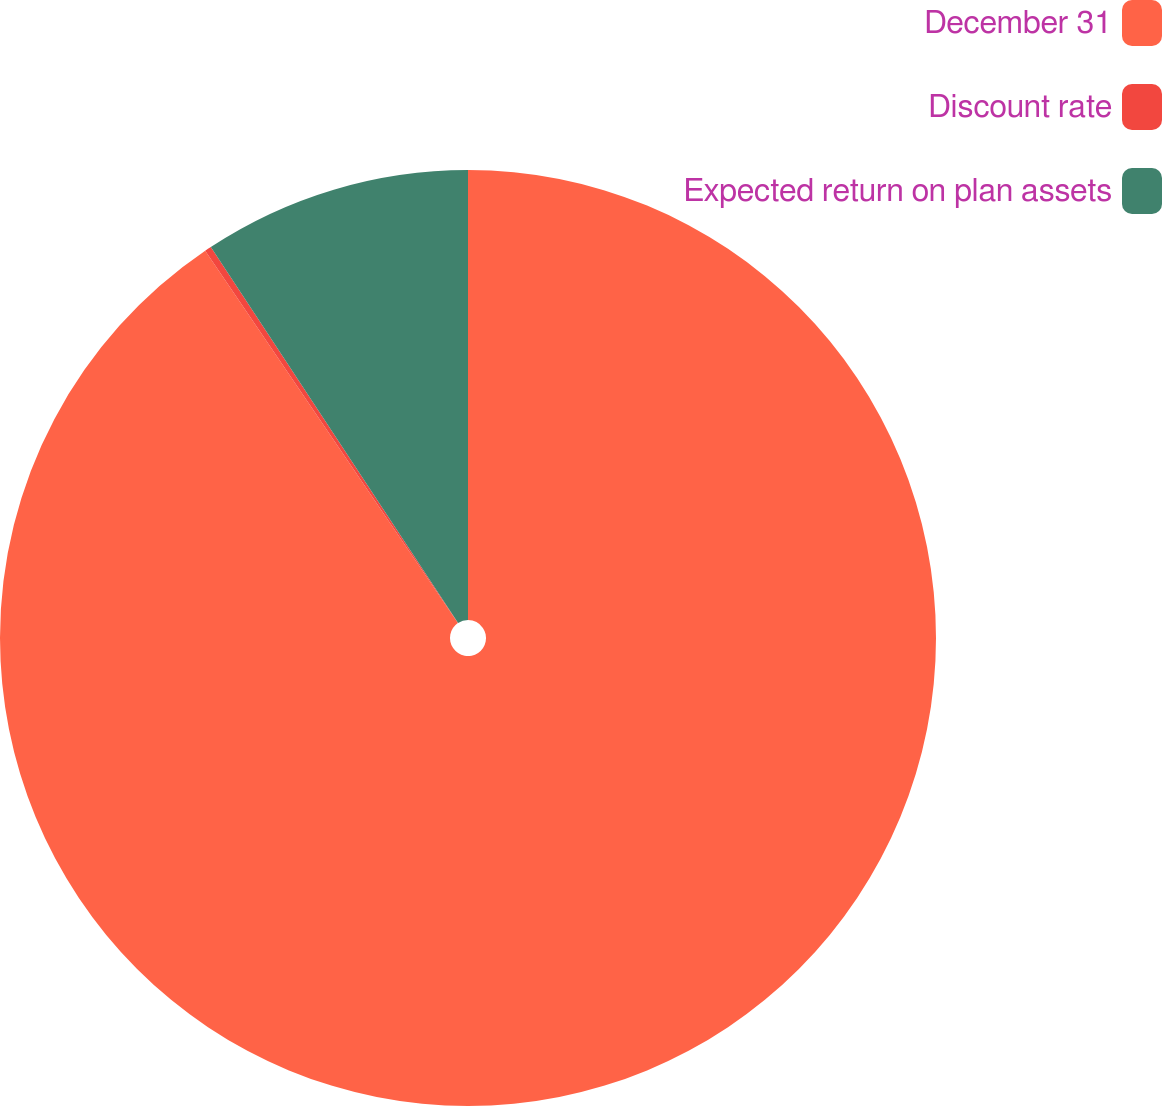Convert chart. <chart><loc_0><loc_0><loc_500><loc_500><pie_chart><fcel>December 31<fcel>Discount rate<fcel>Expected return on plan assets<nl><fcel>90.51%<fcel>0.23%<fcel>9.26%<nl></chart> 